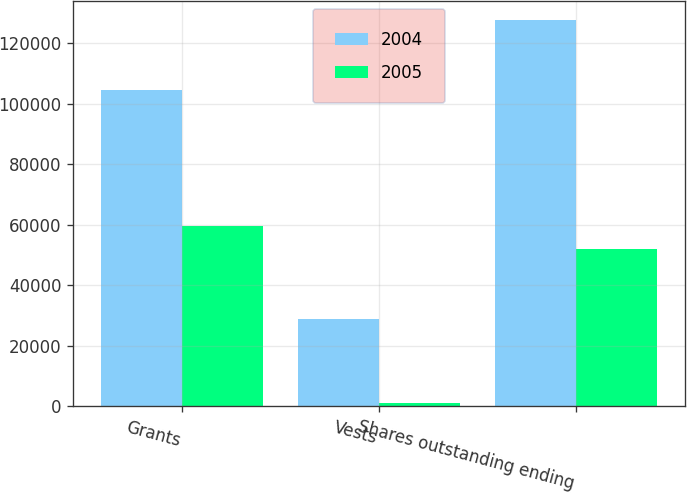Convert chart to OTSL. <chart><loc_0><loc_0><loc_500><loc_500><stacked_bar_chart><ecel><fcel>Grants<fcel>Vests<fcel>Shares outstanding ending<nl><fcel>2004<fcel>104447<fcel>28842<fcel>127601<nl><fcel>2005<fcel>59430<fcel>1262<fcel>51996<nl></chart> 